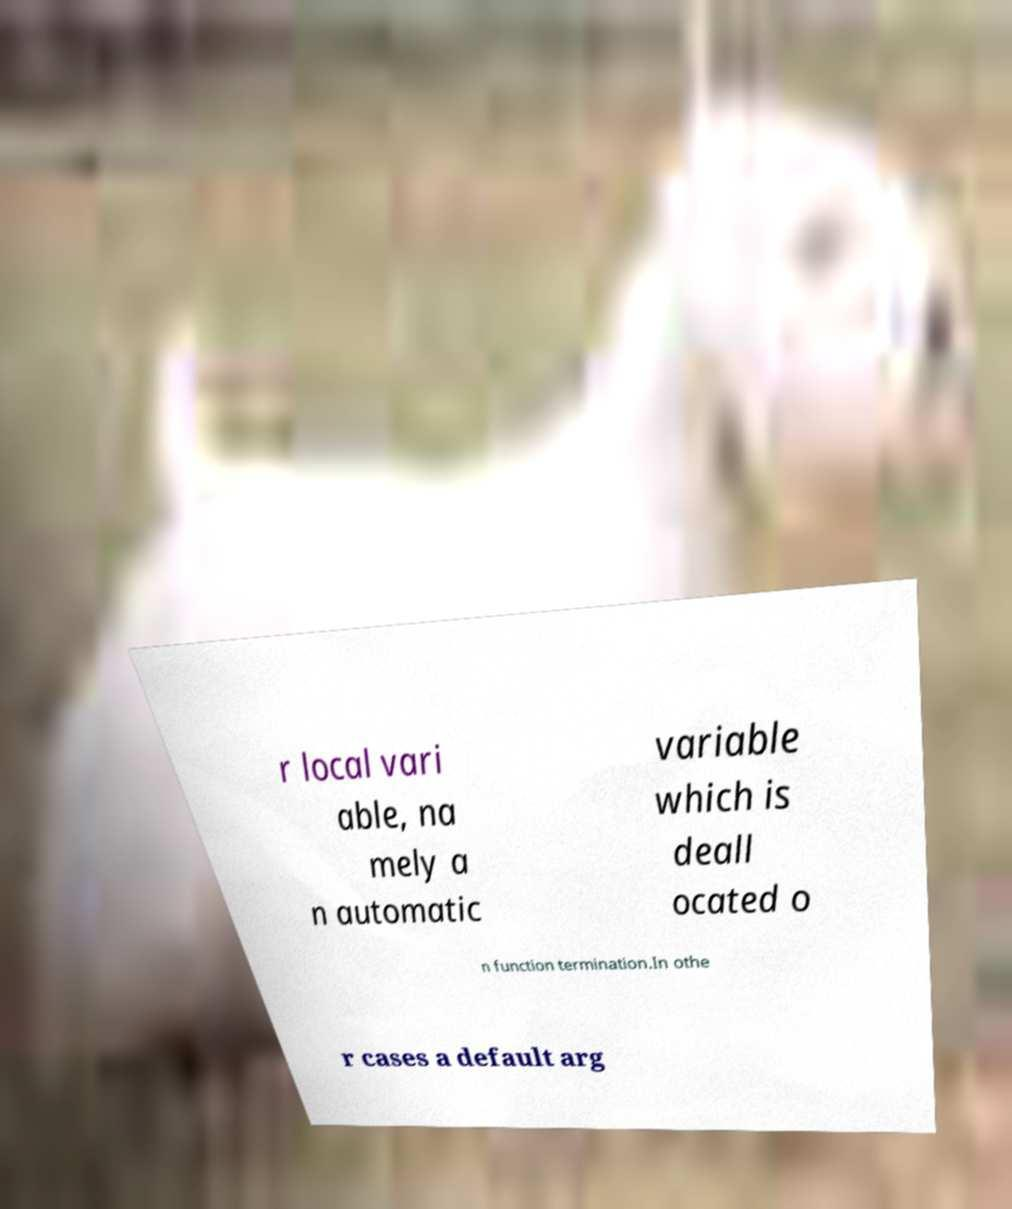Please read and relay the text visible in this image. What does it say? r local vari able, na mely a n automatic variable which is deall ocated o n function termination.In othe r cases a default arg 